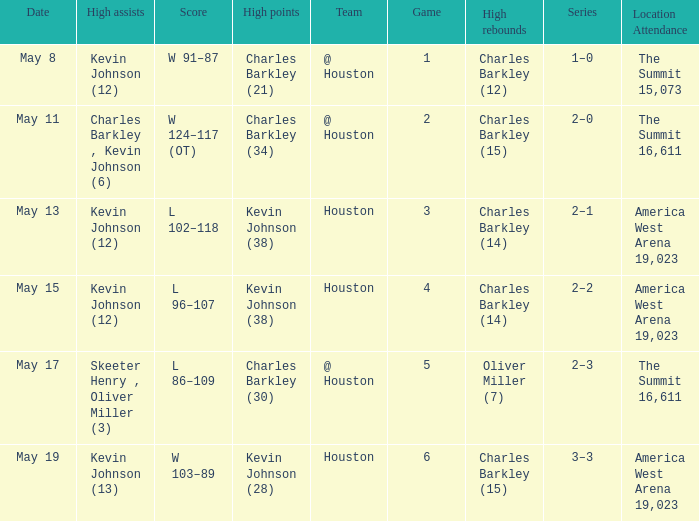Who did the high points in game number 1? Charles Barkley (21). 